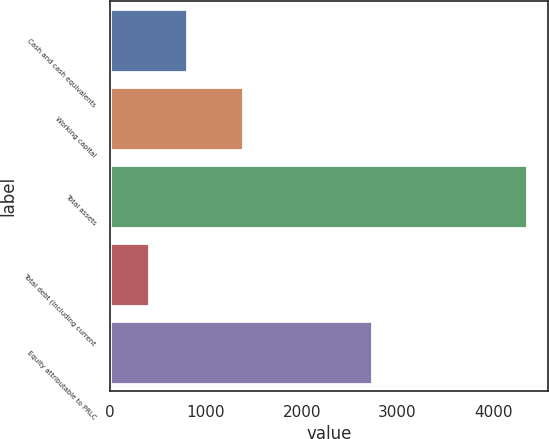Convert chart. <chart><loc_0><loc_0><loc_500><loc_500><bar_chart><fcel>Cash and cash equivalents<fcel>Working capital<fcel>Total assets<fcel>Total debt (including current<fcel>Equity attributable to PRLC<nl><fcel>801.41<fcel>1382.6<fcel>4356.5<fcel>406.4<fcel>2735.1<nl></chart> 